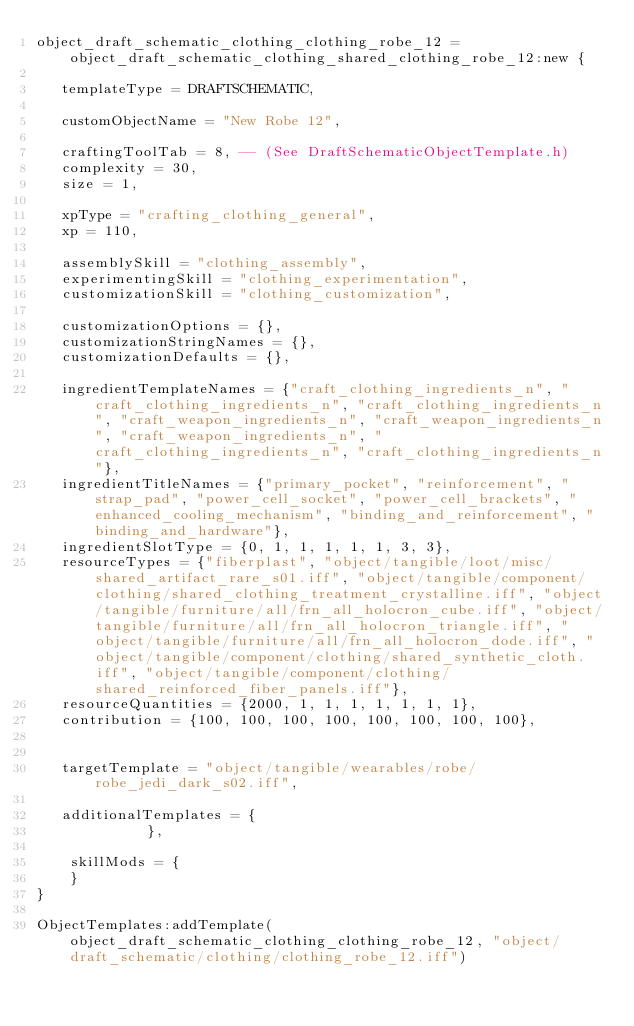Convert code to text. <code><loc_0><loc_0><loc_500><loc_500><_Lua_>object_draft_schematic_clothing_clothing_robe_12 = object_draft_schematic_clothing_shared_clothing_robe_12:new {

   templateType = DRAFTSCHEMATIC,

   customObjectName = "New Robe 12",

   craftingToolTab = 8, -- (See DraftSchematicObjectTemplate.h)
   complexity = 30, 
   size = 1, 

   xpType = "crafting_clothing_general", 
   xp = 110, 

   assemblySkill = "clothing_assembly", 
   experimentingSkill = "clothing_experimentation", 
   customizationSkill = "clothing_customization", 

   customizationOptions = {},
   customizationStringNames = {},
   customizationDefaults = {},

   ingredientTemplateNames = {"craft_clothing_ingredients_n", "craft_clothing_ingredients_n", "craft_clothing_ingredients_n", "craft_weapon_ingredients_n", "craft_weapon_ingredients_n", "craft_weapon_ingredients_n", "craft_clothing_ingredients_n", "craft_clothing_ingredients_n"},
   ingredientTitleNames = {"primary_pocket", "reinforcement", "strap_pad", "power_cell_socket", "power_cell_brackets", "enhanced_cooling_mechanism", "binding_and_reinforcement", "binding_and_hardware"},
   ingredientSlotType = {0, 1, 1, 1, 1, 1, 3, 3},
   resourceTypes = {"fiberplast", "object/tangible/loot/misc/shared_artifact_rare_s01.iff", "object/tangible/component/clothing/shared_clothing_treatment_crystalline.iff", "object/tangible/furniture/all/frn_all_holocron_cube.iff", "object/tangible/furniture/all/frn_all_holocron_triangle.iff", "object/tangible/furniture/all/frn_all_holocron_dode.iff", "object/tangible/component/clothing/shared_synthetic_cloth.iff", "object/tangible/component/clothing/shared_reinforced_fiber_panels.iff"},
   resourceQuantities = {2000, 1, 1, 1, 1, 1, 1, 1},
   contribution = {100, 100, 100, 100, 100, 100, 100, 100},


   targetTemplate = "object/tangible/wearables/robe/robe_jedi_dark_s02.iff",

   additionalTemplates = {
             },
		
	skillMods = {
	}
}

ObjectTemplates:addTemplate(object_draft_schematic_clothing_clothing_robe_12, "object/draft_schematic/clothing/clothing_robe_12.iff")
</code> 